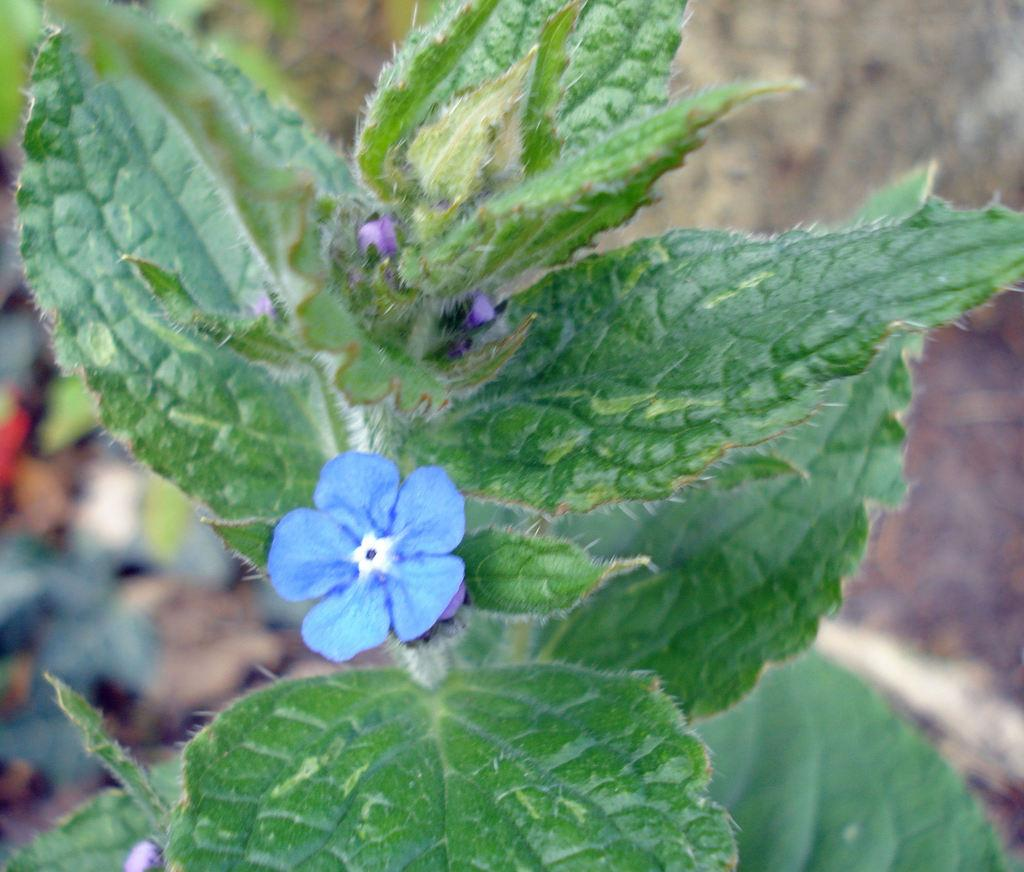What type of plant is in the picture? There is a flower plant in the picture. What color is the flower on the plant? The flower is blue in color. Can you describe the background of the image? The background of the image is blurred. What type of caption is written on the flower in the image? There is no caption written on the flower in the image. Can you tell me where the flower was purchased from in the image? The image does not provide information about where the flower was purchased from. 